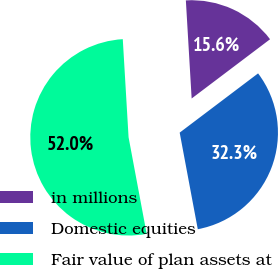Convert chart to OTSL. <chart><loc_0><loc_0><loc_500><loc_500><pie_chart><fcel>in millions<fcel>Domestic equities<fcel>Fair value of plan assets at<nl><fcel>15.64%<fcel>32.35%<fcel>52.01%<nl></chart> 